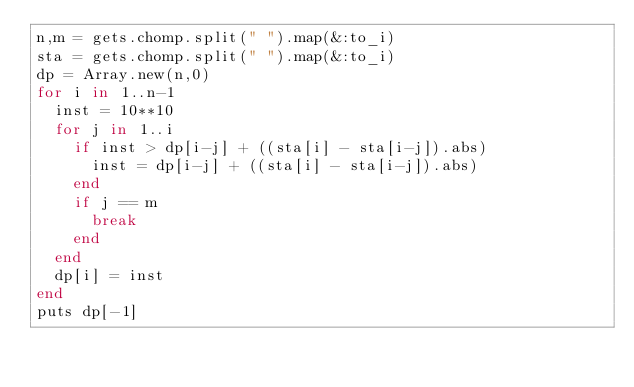Convert code to text. <code><loc_0><loc_0><loc_500><loc_500><_Ruby_>n,m = gets.chomp.split(" ").map(&:to_i)
sta = gets.chomp.split(" ").map(&:to_i)
dp = Array.new(n,0)
for i in 1..n-1
  inst = 10**10
  for j in 1..i
    if inst > dp[i-j] + ((sta[i] - sta[i-j]).abs)
      inst = dp[i-j] + ((sta[i] - sta[i-j]).abs)
    end
    if j == m
      break
    end
  end
  dp[i] = inst
end
puts dp[-1]
</code> 